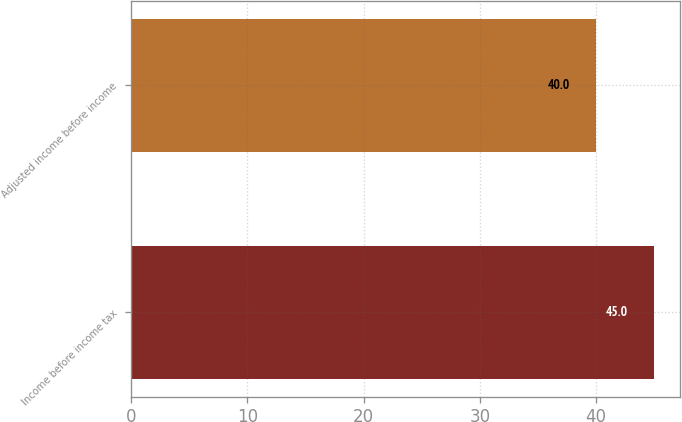Convert chart. <chart><loc_0><loc_0><loc_500><loc_500><bar_chart><fcel>Income before income tax<fcel>Adjusted income before income<nl><fcel>45<fcel>40<nl></chart> 